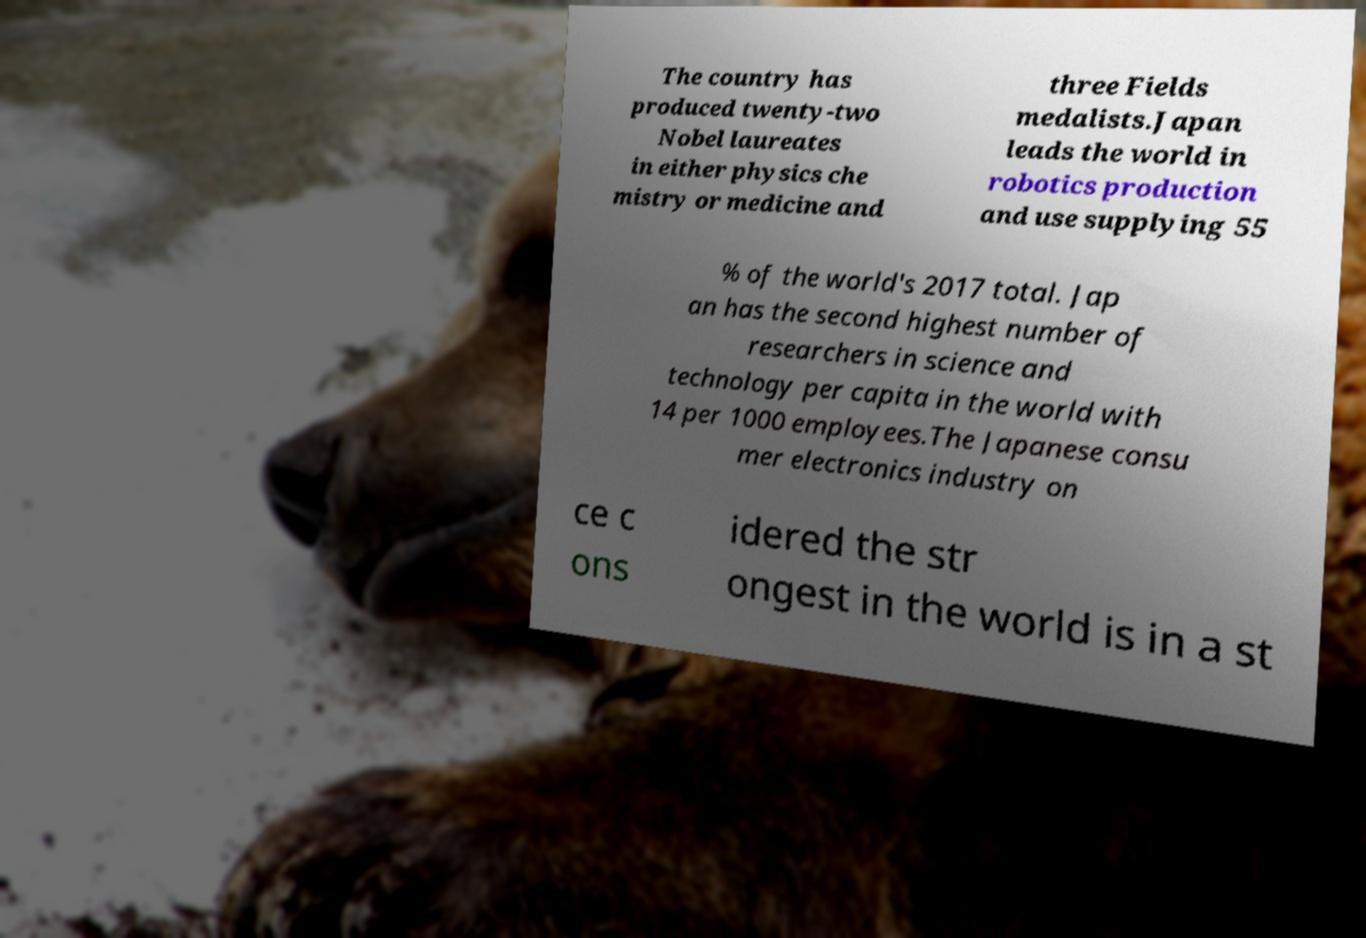I need the written content from this picture converted into text. Can you do that? The country has produced twenty-two Nobel laureates in either physics che mistry or medicine and three Fields medalists.Japan leads the world in robotics production and use supplying 55 % of the world's 2017 total. Jap an has the second highest number of researchers in science and technology per capita in the world with 14 per 1000 employees.The Japanese consu mer electronics industry on ce c ons idered the str ongest in the world is in a st 